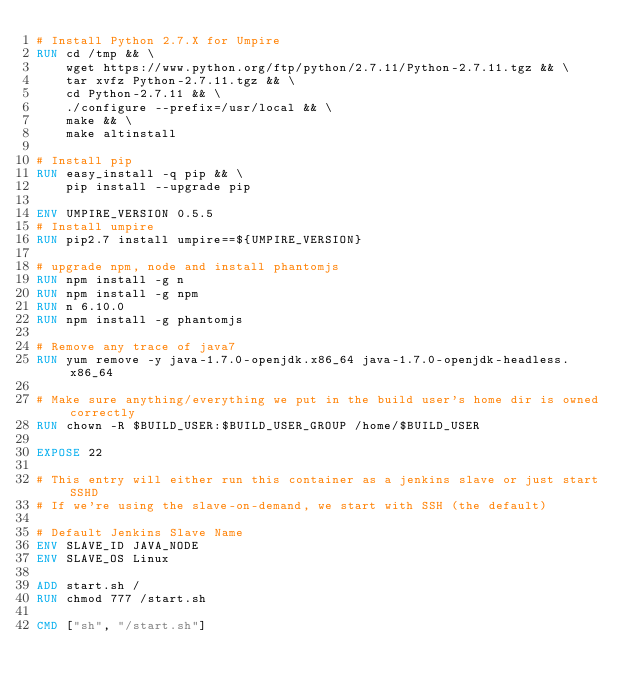Convert code to text. <code><loc_0><loc_0><loc_500><loc_500><_Dockerfile_># Install Python 2.7.X for Umpire
RUN cd /tmp && \
    wget https://www.python.org/ftp/python/2.7.11/Python-2.7.11.tgz && \
    tar xvfz Python-2.7.11.tgz && \
    cd Python-2.7.11 && \
    ./configure --prefix=/usr/local && \
    make && \
    make altinstall

# Install pip
RUN easy_install -q pip && \
    pip install --upgrade pip

ENV UMPIRE_VERSION 0.5.5
# Install umpire
RUN pip2.7 install umpire==${UMPIRE_VERSION}

# upgrade npm, node and install phantomjs
RUN npm install -g n
RUN npm install -g npm
RUN n 6.10.0
RUN npm install -g phantomjs

# Remove any trace of java7
RUN yum remove -y java-1.7.0-openjdk.x86_64 java-1.7.0-openjdk-headless.x86_64

# Make sure anything/everything we put in the build user's home dir is owned correctly
RUN chown -R $BUILD_USER:$BUILD_USER_GROUP /home/$BUILD_USER

EXPOSE 22

# This entry will either run this container as a jenkins slave or just start SSHD
# If we're using the slave-on-demand, we start with SSH (the default)

# Default Jenkins Slave Name
ENV SLAVE_ID JAVA_NODE
ENV SLAVE_OS Linux

ADD start.sh /
RUN chmod 777 /start.sh

CMD ["sh", "/start.sh"]
</code> 